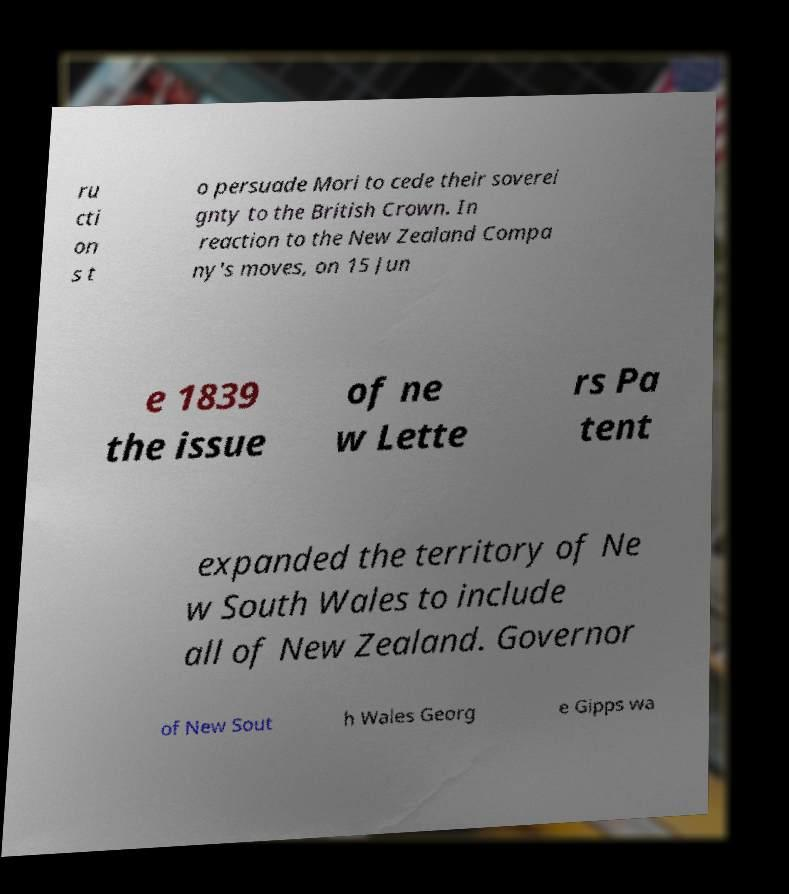Could you extract and type out the text from this image? ru cti on s t o persuade Mori to cede their soverei gnty to the British Crown. In reaction to the New Zealand Compa ny's moves, on 15 Jun e 1839 the issue of ne w Lette rs Pa tent expanded the territory of Ne w South Wales to include all of New Zealand. Governor of New Sout h Wales Georg e Gipps wa 